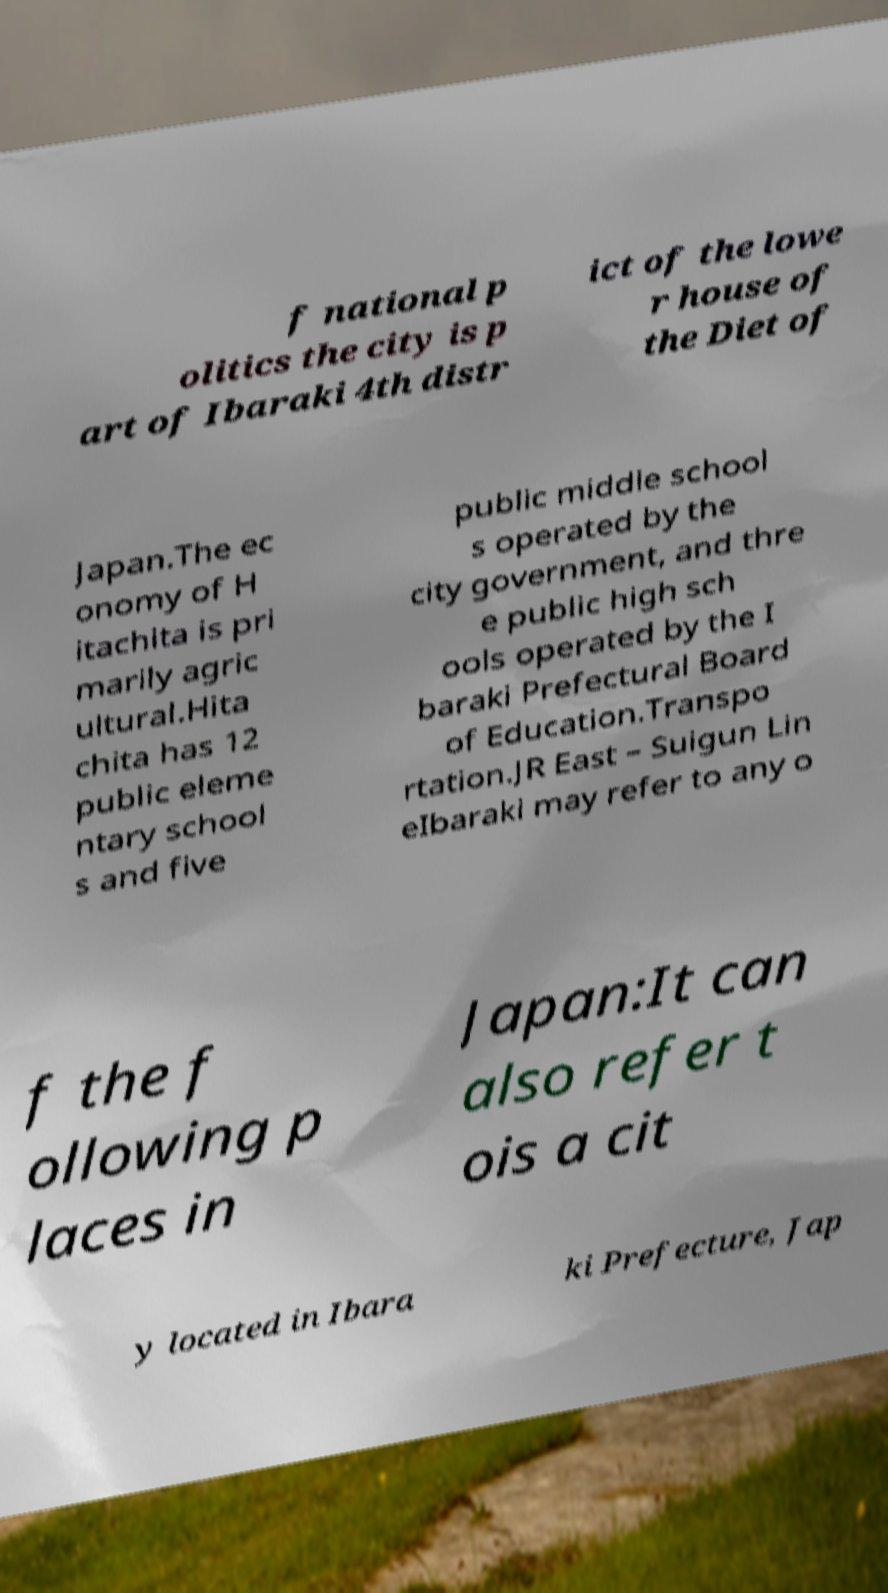What messages or text are displayed in this image? I need them in a readable, typed format. f national p olitics the city is p art of Ibaraki 4th distr ict of the lowe r house of the Diet of Japan.The ec onomy of H itachita is pri marily agric ultural.Hita chita has 12 public eleme ntary school s and five public middle school s operated by the city government, and thre e public high sch ools operated by the I baraki Prefectural Board of Education.Transpo rtation.JR East – Suigun Lin eIbaraki may refer to any o f the f ollowing p laces in Japan:It can also refer t ois a cit y located in Ibara ki Prefecture, Jap 